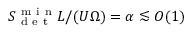<formula> <loc_0><loc_0><loc_500><loc_500>S _ { d e t } ^ { m i n } L / ( U \Omega ) = \alpha \lesssim O ( 1 )</formula> 